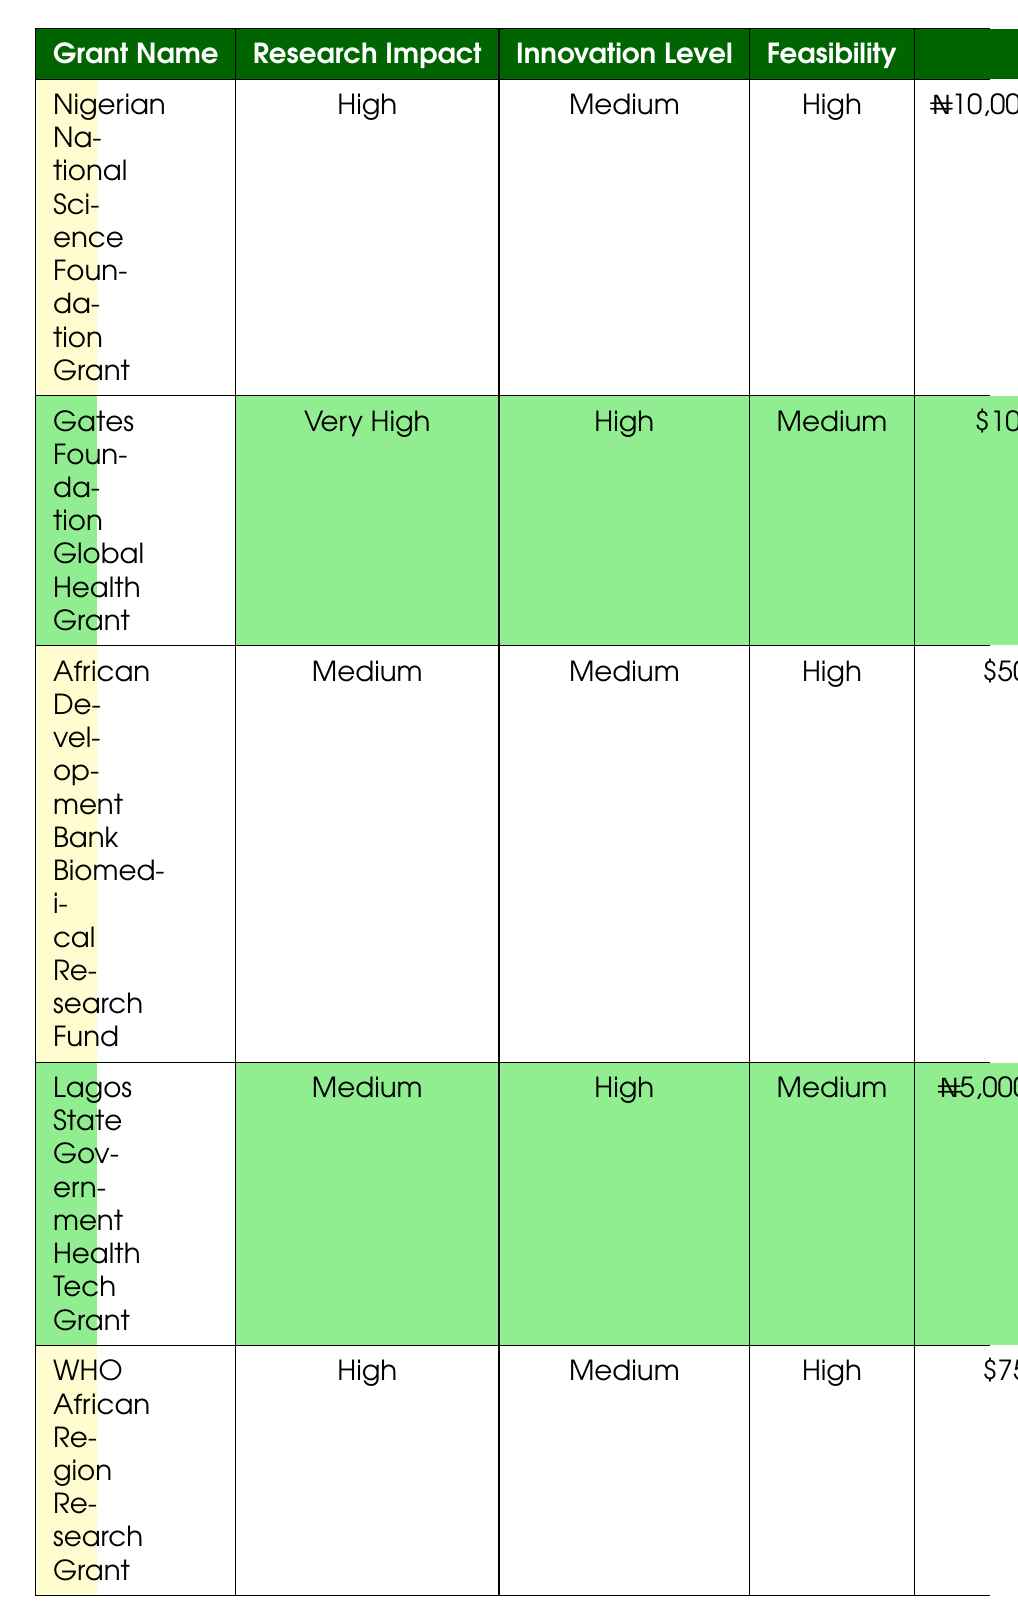What is the budget range for the Nigerian National Science Foundation Grant? The table lists the budget range for the Nigerian National Science Foundation Grant as ₦10,000,000 - ₦20,000,000.
Answer: ₦10,000,000 - ₦20,000,000 Which grant has the highest innovation level? According to the table, the Gates Foundation Global Health Grant has a high innovation level, which is the highest level mentioned.
Answer: Gates Foundation Global Health Grant Is the team qualification for the Lagos State Government Health Tech Grant a Bachelor's degree? The table states that the qualifications for the Lagos State Government Health Tech Grant are "Bachelors with proven experience," so the answer is yes.
Answer: Yes How many grants have a research impact rated as high? The Nigerian National Science Foundation Grant and WHO African Region Research Grant both have a research impact rated as high, giving a total of 2 grants.
Answer: 2 What is the average budget range for grants with high feasibility? The grants with high feasibility are the Nigerian National Science Foundation Grant, African Development Bank Biomedical Research Fund, and WHO African Region Research Grant. Their budget ranges are ₦10,000,000 - ₦20,000,000, $50,000 - $150,000, and $75,000 - $200,000 respectively. To find the average, we convert all budgets into the same currency and calculate. The total budget in USD is approximately 25,000 (for the Nigerian grant) + 50,000 + 75,000 = 150,000. There are 3 grants, so the average budget is 150,000 / 3 = $50,000.
Answer: $50,000 Are there any grants that do not align strongly with Nigerian health priorities? The table displays that the Gates Foundation Global Health Grant has a medium alignment with Nigerian health priorities, while all other grants have high or very strong alignment. Therefore, the answer is yes.
Answer: Yes 